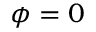<formula> <loc_0><loc_0><loc_500><loc_500>\phi = 0</formula> 